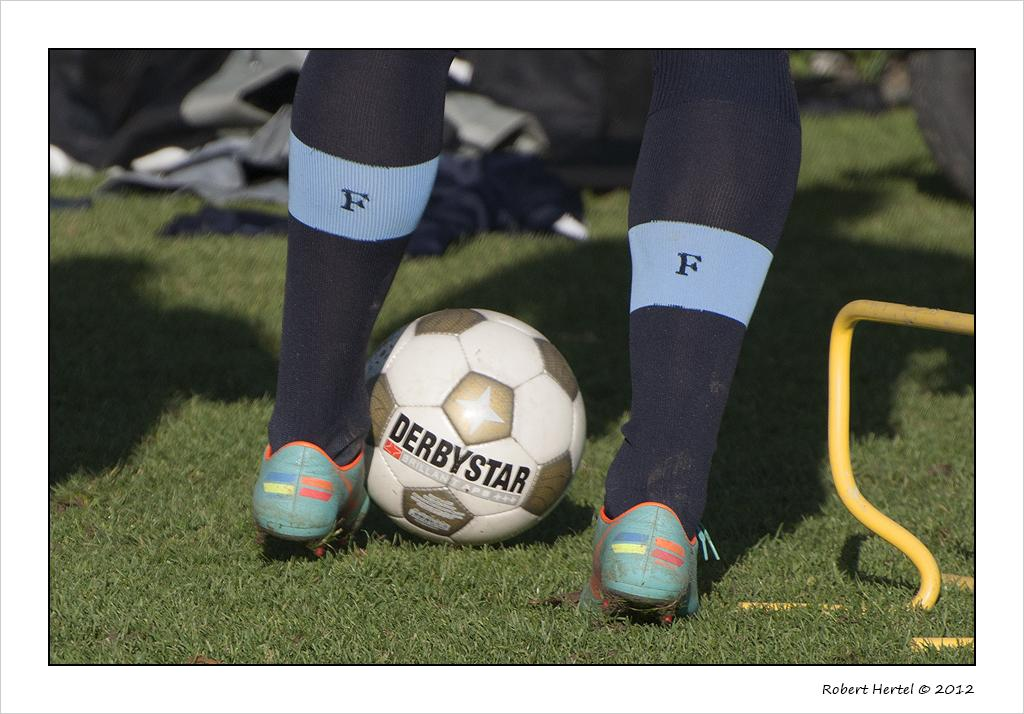What can be seen in the image that belongs to a person? There are two legs of a person in the image. What object is on the ground beside the left leg? There is a ball on the ground beside the left leg. How would you describe the background of the image? The background of the image is blurry. What type of veil is draped over the person's legs in the image? There is no veil present in the image; only the person's legs and a ball on the ground are visible. 